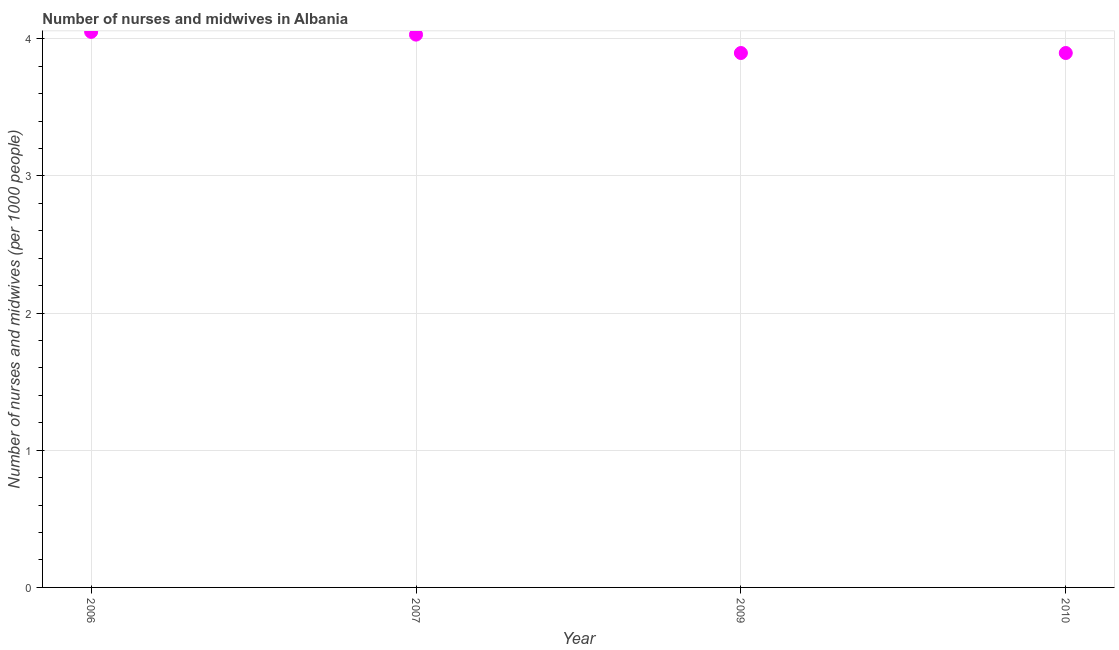What is the number of nurses and midwives in 2007?
Your answer should be very brief. 4.03. Across all years, what is the maximum number of nurses and midwives?
Keep it short and to the point. 4.05. Across all years, what is the minimum number of nurses and midwives?
Keep it short and to the point. 3.9. In which year was the number of nurses and midwives minimum?
Keep it short and to the point. 2009. What is the sum of the number of nurses and midwives?
Give a very brief answer. 15.87. What is the difference between the number of nurses and midwives in 2007 and 2010?
Ensure brevity in your answer.  0.13. What is the average number of nurses and midwives per year?
Your answer should be very brief. 3.97. What is the median number of nurses and midwives?
Your answer should be compact. 3.96. What is the ratio of the number of nurses and midwives in 2009 to that in 2010?
Provide a short and direct response. 1. What is the difference between the highest and the second highest number of nurses and midwives?
Give a very brief answer. 0.02. Is the sum of the number of nurses and midwives in 2007 and 2010 greater than the maximum number of nurses and midwives across all years?
Ensure brevity in your answer.  Yes. What is the difference between the highest and the lowest number of nurses and midwives?
Your response must be concise. 0.15. In how many years, is the number of nurses and midwives greater than the average number of nurses and midwives taken over all years?
Ensure brevity in your answer.  2. Does the number of nurses and midwives monotonically increase over the years?
Your answer should be very brief. No. What is the difference between two consecutive major ticks on the Y-axis?
Your answer should be very brief. 1. Are the values on the major ticks of Y-axis written in scientific E-notation?
Your answer should be compact. No. Does the graph contain any zero values?
Provide a succinct answer. No. What is the title of the graph?
Offer a terse response. Number of nurses and midwives in Albania. What is the label or title of the Y-axis?
Ensure brevity in your answer.  Number of nurses and midwives (per 1000 people). What is the Number of nurses and midwives (per 1000 people) in 2006?
Offer a terse response. 4.05. What is the Number of nurses and midwives (per 1000 people) in 2007?
Offer a very short reply. 4.03. What is the Number of nurses and midwives (per 1000 people) in 2009?
Your response must be concise. 3.9. What is the Number of nurses and midwives (per 1000 people) in 2010?
Ensure brevity in your answer.  3.9. What is the difference between the Number of nurses and midwives (per 1000 people) in 2006 and 2007?
Provide a short and direct response. 0.02. What is the difference between the Number of nurses and midwives (per 1000 people) in 2006 and 2009?
Provide a succinct answer. 0.15. What is the difference between the Number of nurses and midwives (per 1000 people) in 2006 and 2010?
Give a very brief answer. 0.15. What is the difference between the Number of nurses and midwives (per 1000 people) in 2007 and 2009?
Ensure brevity in your answer.  0.13. What is the difference between the Number of nurses and midwives (per 1000 people) in 2007 and 2010?
Make the answer very short. 0.13. What is the ratio of the Number of nurses and midwives (per 1000 people) in 2006 to that in 2010?
Give a very brief answer. 1.04. What is the ratio of the Number of nurses and midwives (per 1000 people) in 2007 to that in 2009?
Your answer should be very brief. 1.03. What is the ratio of the Number of nurses and midwives (per 1000 people) in 2007 to that in 2010?
Provide a succinct answer. 1.03. 